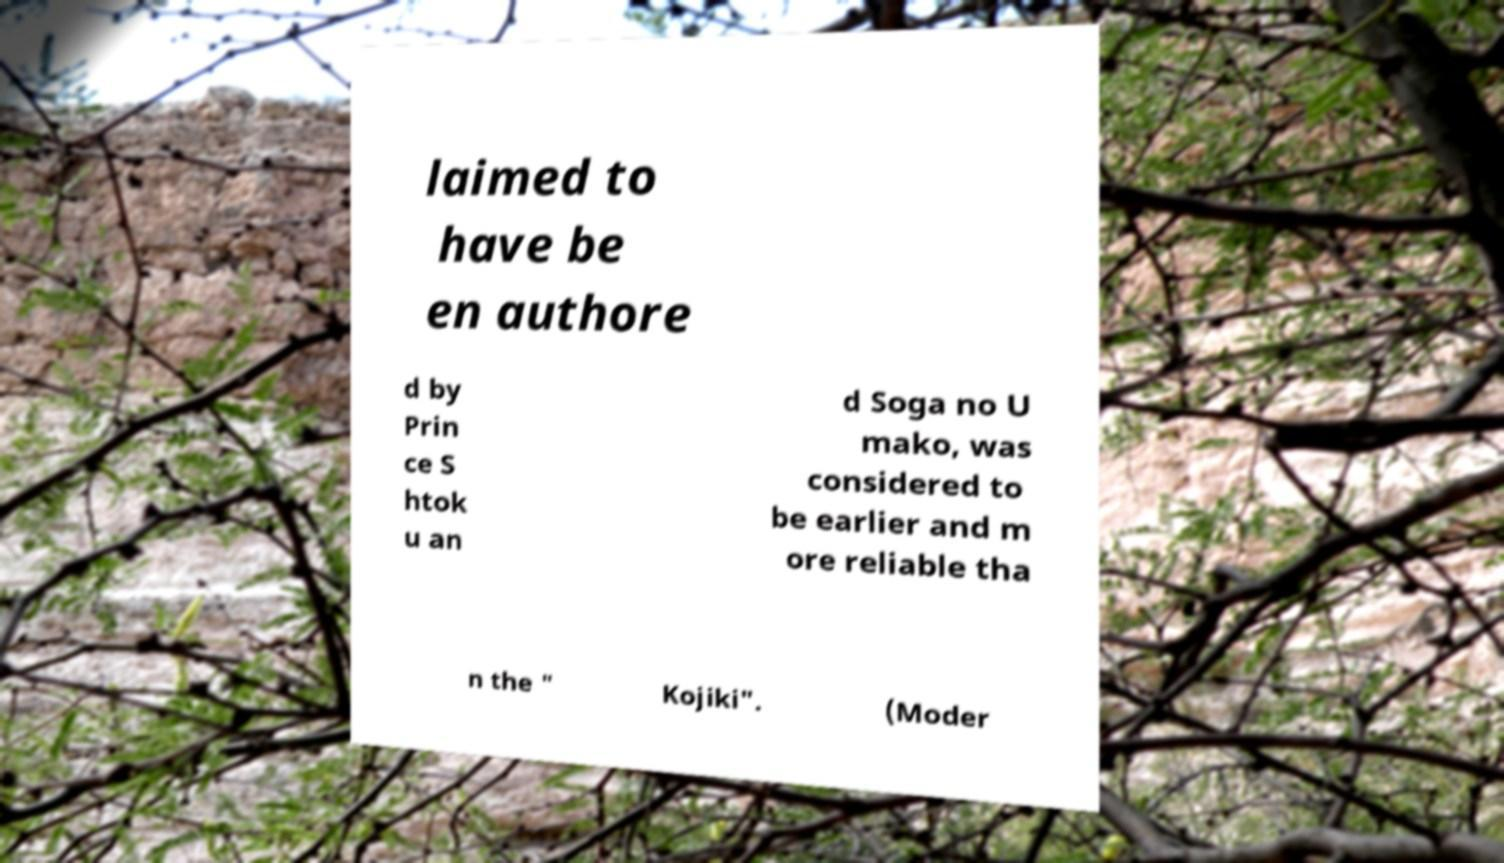For documentation purposes, I need the text within this image transcribed. Could you provide that? laimed to have be en authore d by Prin ce S htok u an d Soga no U mako, was considered to be earlier and m ore reliable tha n the " Kojiki". (Moder 